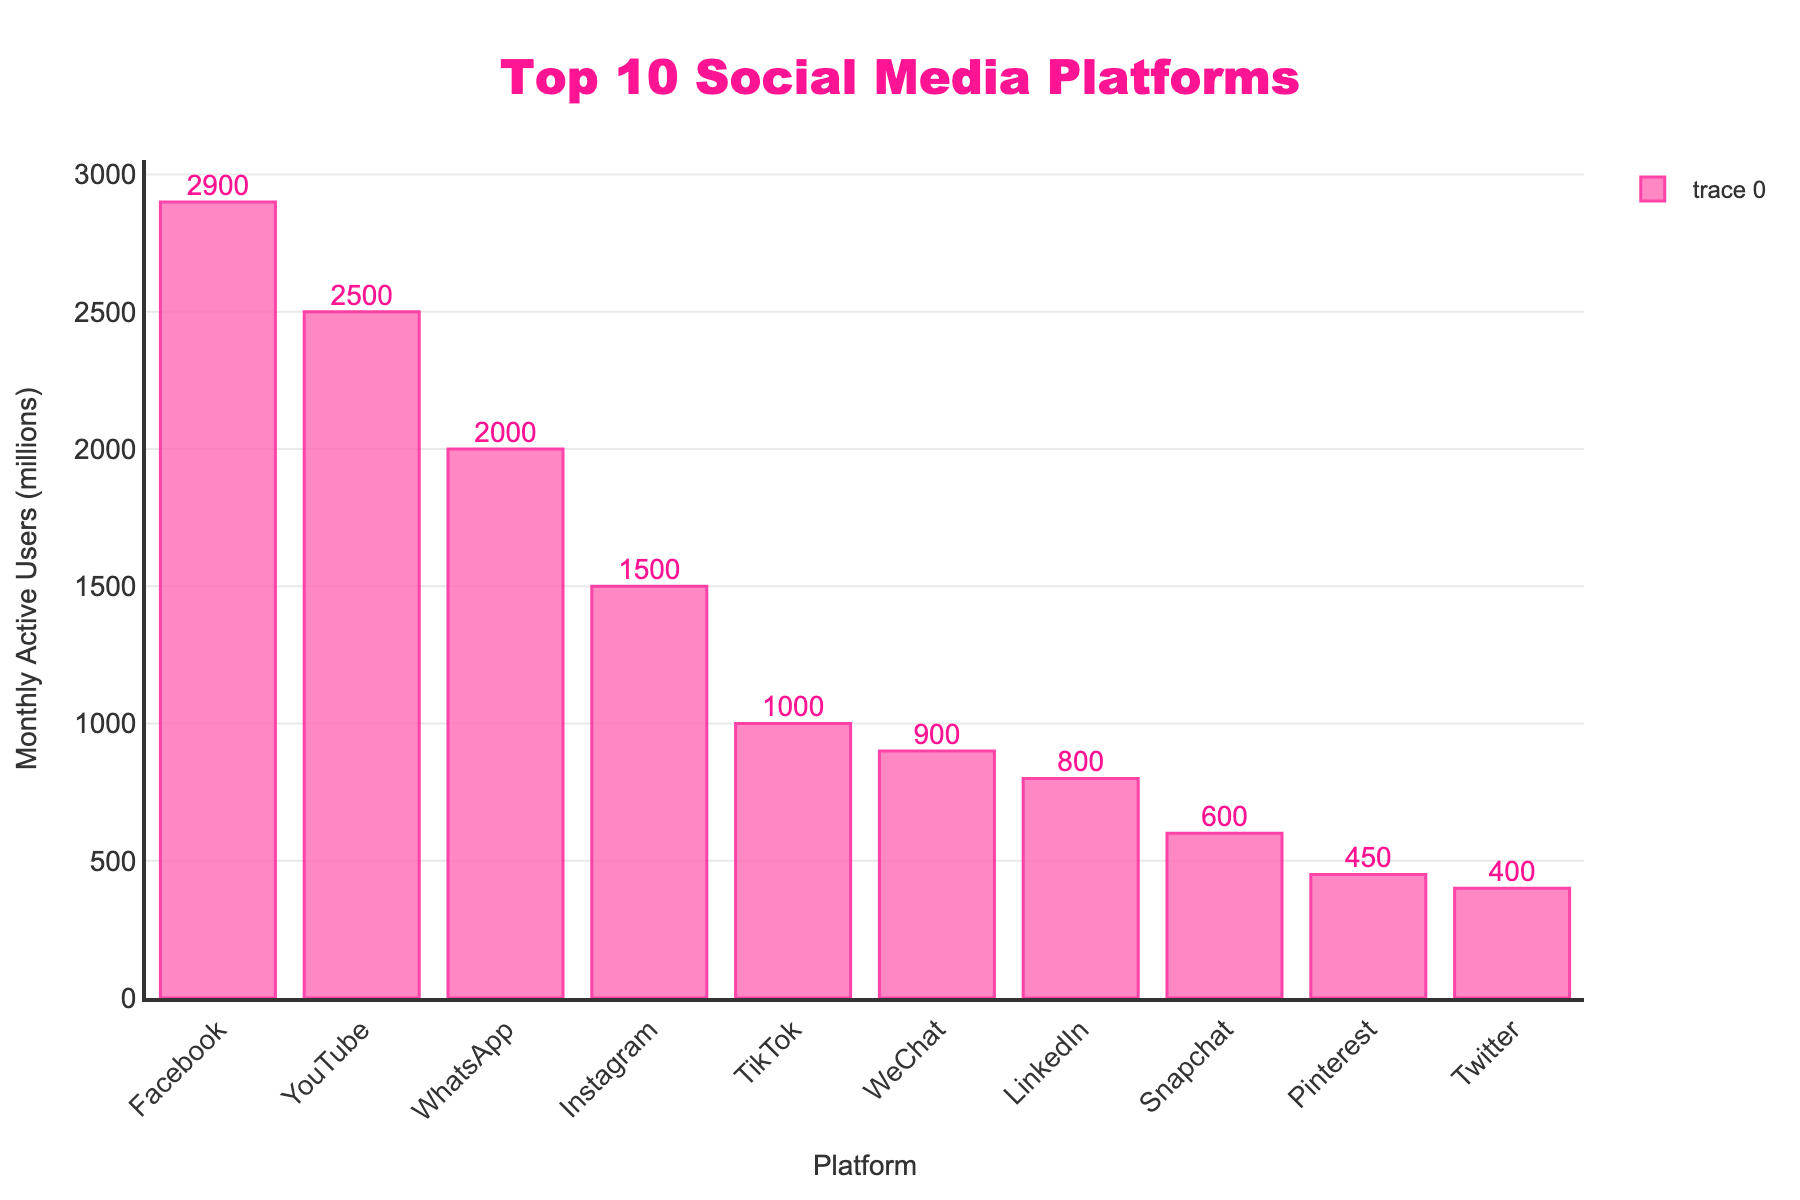What is the most popular social media platform by monthly active users? The bar chart shows the heights of bars representing monthly active users for each platform. The tallest bar corresponds to Facebook.
Answer: Facebook Which platforms have more than 1.5 billion monthly active users? Look at the bars that exceed 1.5 billion on the y-axis. These are Facebook, YouTube, and WhatsApp.
Answer: Facebook, YouTube, WhatsApp What is the sum of monthly active users for TikTok and WeChat? TikTok has 1000 million and WeChat has 900 million users. Adding them gives 1000 + 900 = 1900 million.
Answer: 1900 million How many platforms have fewer than 500 million monthly active users? Count the bars that do not reach 500 million on the y-axis. These are Snapchat, Pinterest, and Twitter. There are 3 platforms.
Answer: 3 Which platform has the lowest number of monthly active users? The shortest bar, corresponding to the lowest number of monthly active users, is Twitter with 400 million users.
Answer: Twitter What's the difference between the monthly active users of Instagram and LinkedIn? Instagram has 1500 million users, and LinkedIn has 800 million users. The difference is 1500 - 800 = 700 million.
Answer: 700 million What is the average number of monthly active users for the platforms listed? Sum all monthly active users for the platforms (2900+2500+2000+1500+1000+900+800+600+450+400 = 14050 million) and divide by the number of platforms (10). The average is 14050 / 10 = 1405 million.
Answer: 1405 million Between Snapchat and Pinterest, which platform is more popular? The bar for Snapchat is taller, indicating it has more monthly active users than Pinterest.
Answer: Snapchat What proportion of the total monthly active users is represented by Facebook? The total number of users across all platforms is 14050 million. Facebook has 2900 million users. The proportion is 2900 / 14050 ≈ 0.206 or 20.6%.
Answer: 20.6% 